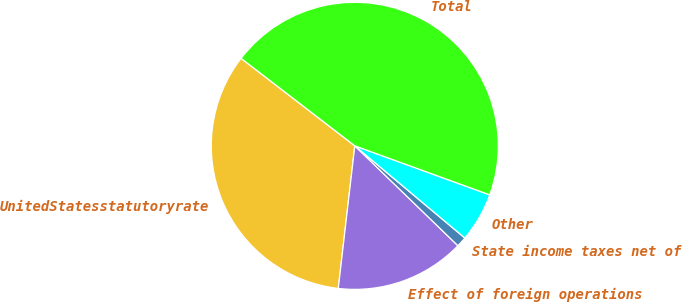<chart> <loc_0><loc_0><loc_500><loc_500><pie_chart><fcel>UnitedStatesstatutoryrate<fcel>Effect of foreign operations<fcel>State income taxes net of<fcel>Other<fcel>Total<nl><fcel>33.6%<fcel>14.59%<fcel>1.15%<fcel>5.55%<fcel>45.11%<nl></chart> 